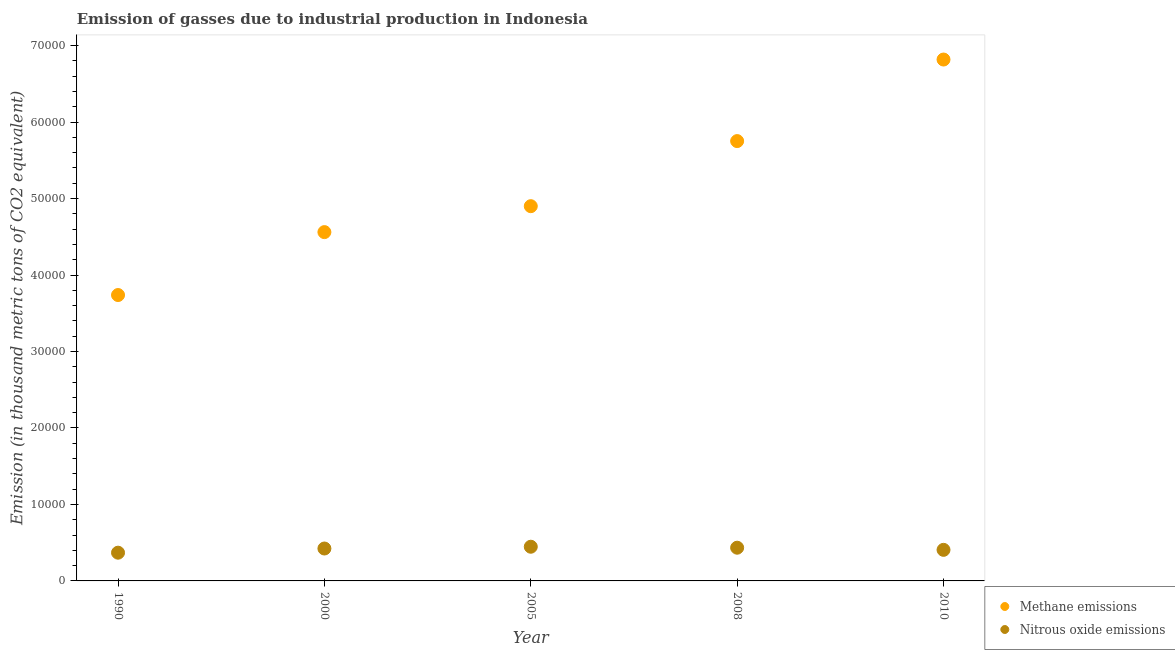What is the amount of methane emissions in 1990?
Provide a short and direct response. 3.74e+04. Across all years, what is the maximum amount of nitrous oxide emissions?
Keep it short and to the point. 4470.7. Across all years, what is the minimum amount of methane emissions?
Ensure brevity in your answer.  3.74e+04. In which year was the amount of nitrous oxide emissions minimum?
Your response must be concise. 1990. What is the total amount of methane emissions in the graph?
Your answer should be compact. 2.58e+05. What is the difference between the amount of nitrous oxide emissions in 2000 and that in 2010?
Make the answer very short. 174.5. What is the difference between the amount of methane emissions in 2010 and the amount of nitrous oxide emissions in 2008?
Provide a succinct answer. 6.38e+04. What is the average amount of methane emissions per year?
Offer a very short reply. 5.15e+04. In the year 2008, what is the difference between the amount of methane emissions and amount of nitrous oxide emissions?
Your answer should be compact. 5.32e+04. In how many years, is the amount of nitrous oxide emissions greater than 58000 thousand metric tons?
Your answer should be very brief. 0. What is the ratio of the amount of nitrous oxide emissions in 1990 to that in 2010?
Provide a succinct answer. 0.91. What is the difference between the highest and the second highest amount of methane emissions?
Make the answer very short. 1.07e+04. What is the difference between the highest and the lowest amount of nitrous oxide emissions?
Your response must be concise. 778.3. In how many years, is the amount of nitrous oxide emissions greater than the average amount of nitrous oxide emissions taken over all years?
Provide a succinct answer. 3. Does the amount of methane emissions monotonically increase over the years?
Provide a succinct answer. Yes. Is the amount of nitrous oxide emissions strictly greater than the amount of methane emissions over the years?
Your answer should be very brief. No. Is the amount of nitrous oxide emissions strictly less than the amount of methane emissions over the years?
Keep it short and to the point. Yes. How many dotlines are there?
Make the answer very short. 2. How many years are there in the graph?
Make the answer very short. 5. Are the values on the major ticks of Y-axis written in scientific E-notation?
Offer a terse response. No. Does the graph contain any zero values?
Keep it short and to the point. No. What is the title of the graph?
Your answer should be very brief. Emission of gasses due to industrial production in Indonesia. Does "Formally registered" appear as one of the legend labels in the graph?
Offer a terse response. No. What is the label or title of the X-axis?
Make the answer very short. Year. What is the label or title of the Y-axis?
Offer a very short reply. Emission (in thousand metric tons of CO2 equivalent). What is the Emission (in thousand metric tons of CO2 equivalent) in Methane emissions in 1990?
Offer a very short reply. 3.74e+04. What is the Emission (in thousand metric tons of CO2 equivalent) of Nitrous oxide emissions in 1990?
Provide a succinct answer. 3692.4. What is the Emission (in thousand metric tons of CO2 equivalent) of Methane emissions in 2000?
Give a very brief answer. 4.56e+04. What is the Emission (in thousand metric tons of CO2 equivalent) of Nitrous oxide emissions in 2000?
Your answer should be very brief. 4237.9. What is the Emission (in thousand metric tons of CO2 equivalent) of Methane emissions in 2005?
Your response must be concise. 4.90e+04. What is the Emission (in thousand metric tons of CO2 equivalent) in Nitrous oxide emissions in 2005?
Give a very brief answer. 4470.7. What is the Emission (in thousand metric tons of CO2 equivalent) of Methane emissions in 2008?
Ensure brevity in your answer.  5.75e+04. What is the Emission (in thousand metric tons of CO2 equivalent) of Nitrous oxide emissions in 2008?
Make the answer very short. 4343.7. What is the Emission (in thousand metric tons of CO2 equivalent) of Methane emissions in 2010?
Provide a short and direct response. 6.82e+04. What is the Emission (in thousand metric tons of CO2 equivalent) of Nitrous oxide emissions in 2010?
Offer a terse response. 4063.4. Across all years, what is the maximum Emission (in thousand metric tons of CO2 equivalent) of Methane emissions?
Make the answer very short. 6.82e+04. Across all years, what is the maximum Emission (in thousand metric tons of CO2 equivalent) of Nitrous oxide emissions?
Ensure brevity in your answer.  4470.7. Across all years, what is the minimum Emission (in thousand metric tons of CO2 equivalent) in Methane emissions?
Provide a short and direct response. 3.74e+04. Across all years, what is the minimum Emission (in thousand metric tons of CO2 equivalent) in Nitrous oxide emissions?
Provide a succinct answer. 3692.4. What is the total Emission (in thousand metric tons of CO2 equivalent) in Methane emissions in the graph?
Your response must be concise. 2.58e+05. What is the total Emission (in thousand metric tons of CO2 equivalent) in Nitrous oxide emissions in the graph?
Make the answer very short. 2.08e+04. What is the difference between the Emission (in thousand metric tons of CO2 equivalent) in Methane emissions in 1990 and that in 2000?
Your answer should be very brief. -8228.1. What is the difference between the Emission (in thousand metric tons of CO2 equivalent) in Nitrous oxide emissions in 1990 and that in 2000?
Offer a terse response. -545.5. What is the difference between the Emission (in thousand metric tons of CO2 equivalent) of Methane emissions in 1990 and that in 2005?
Provide a succinct answer. -1.16e+04. What is the difference between the Emission (in thousand metric tons of CO2 equivalent) in Nitrous oxide emissions in 1990 and that in 2005?
Make the answer very short. -778.3. What is the difference between the Emission (in thousand metric tons of CO2 equivalent) of Methane emissions in 1990 and that in 2008?
Your response must be concise. -2.01e+04. What is the difference between the Emission (in thousand metric tons of CO2 equivalent) in Nitrous oxide emissions in 1990 and that in 2008?
Offer a terse response. -651.3. What is the difference between the Emission (in thousand metric tons of CO2 equivalent) of Methane emissions in 1990 and that in 2010?
Your answer should be very brief. -3.08e+04. What is the difference between the Emission (in thousand metric tons of CO2 equivalent) in Nitrous oxide emissions in 1990 and that in 2010?
Offer a very short reply. -371. What is the difference between the Emission (in thousand metric tons of CO2 equivalent) of Methane emissions in 2000 and that in 2005?
Your answer should be very brief. -3391.6. What is the difference between the Emission (in thousand metric tons of CO2 equivalent) of Nitrous oxide emissions in 2000 and that in 2005?
Give a very brief answer. -232.8. What is the difference between the Emission (in thousand metric tons of CO2 equivalent) in Methane emissions in 2000 and that in 2008?
Your answer should be compact. -1.19e+04. What is the difference between the Emission (in thousand metric tons of CO2 equivalent) of Nitrous oxide emissions in 2000 and that in 2008?
Offer a terse response. -105.8. What is the difference between the Emission (in thousand metric tons of CO2 equivalent) of Methane emissions in 2000 and that in 2010?
Provide a succinct answer. -2.26e+04. What is the difference between the Emission (in thousand metric tons of CO2 equivalent) in Nitrous oxide emissions in 2000 and that in 2010?
Offer a terse response. 174.5. What is the difference between the Emission (in thousand metric tons of CO2 equivalent) of Methane emissions in 2005 and that in 2008?
Keep it short and to the point. -8512.6. What is the difference between the Emission (in thousand metric tons of CO2 equivalent) of Nitrous oxide emissions in 2005 and that in 2008?
Your answer should be compact. 127. What is the difference between the Emission (in thousand metric tons of CO2 equivalent) in Methane emissions in 2005 and that in 2010?
Provide a succinct answer. -1.92e+04. What is the difference between the Emission (in thousand metric tons of CO2 equivalent) of Nitrous oxide emissions in 2005 and that in 2010?
Offer a terse response. 407.3. What is the difference between the Emission (in thousand metric tons of CO2 equivalent) of Methane emissions in 2008 and that in 2010?
Offer a terse response. -1.07e+04. What is the difference between the Emission (in thousand metric tons of CO2 equivalent) of Nitrous oxide emissions in 2008 and that in 2010?
Your answer should be very brief. 280.3. What is the difference between the Emission (in thousand metric tons of CO2 equivalent) in Methane emissions in 1990 and the Emission (in thousand metric tons of CO2 equivalent) in Nitrous oxide emissions in 2000?
Provide a short and direct response. 3.31e+04. What is the difference between the Emission (in thousand metric tons of CO2 equivalent) in Methane emissions in 1990 and the Emission (in thousand metric tons of CO2 equivalent) in Nitrous oxide emissions in 2005?
Your response must be concise. 3.29e+04. What is the difference between the Emission (in thousand metric tons of CO2 equivalent) of Methane emissions in 1990 and the Emission (in thousand metric tons of CO2 equivalent) of Nitrous oxide emissions in 2008?
Provide a succinct answer. 3.30e+04. What is the difference between the Emission (in thousand metric tons of CO2 equivalent) of Methane emissions in 1990 and the Emission (in thousand metric tons of CO2 equivalent) of Nitrous oxide emissions in 2010?
Ensure brevity in your answer.  3.33e+04. What is the difference between the Emission (in thousand metric tons of CO2 equivalent) in Methane emissions in 2000 and the Emission (in thousand metric tons of CO2 equivalent) in Nitrous oxide emissions in 2005?
Keep it short and to the point. 4.11e+04. What is the difference between the Emission (in thousand metric tons of CO2 equivalent) in Methane emissions in 2000 and the Emission (in thousand metric tons of CO2 equivalent) in Nitrous oxide emissions in 2008?
Provide a succinct answer. 4.13e+04. What is the difference between the Emission (in thousand metric tons of CO2 equivalent) of Methane emissions in 2000 and the Emission (in thousand metric tons of CO2 equivalent) of Nitrous oxide emissions in 2010?
Offer a very short reply. 4.16e+04. What is the difference between the Emission (in thousand metric tons of CO2 equivalent) in Methane emissions in 2005 and the Emission (in thousand metric tons of CO2 equivalent) in Nitrous oxide emissions in 2008?
Your answer should be very brief. 4.47e+04. What is the difference between the Emission (in thousand metric tons of CO2 equivalent) in Methane emissions in 2005 and the Emission (in thousand metric tons of CO2 equivalent) in Nitrous oxide emissions in 2010?
Ensure brevity in your answer.  4.49e+04. What is the difference between the Emission (in thousand metric tons of CO2 equivalent) in Methane emissions in 2008 and the Emission (in thousand metric tons of CO2 equivalent) in Nitrous oxide emissions in 2010?
Ensure brevity in your answer.  5.35e+04. What is the average Emission (in thousand metric tons of CO2 equivalent) in Methane emissions per year?
Give a very brief answer. 5.15e+04. What is the average Emission (in thousand metric tons of CO2 equivalent) of Nitrous oxide emissions per year?
Provide a short and direct response. 4161.62. In the year 1990, what is the difference between the Emission (in thousand metric tons of CO2 equivalent) of Methane emissions and Emission (in thousand metric tons of CO2 equivalent) of Nitrous oxide emissions?
Make the answer very short. 3.37e+04. In the year 2000, what is the difference between the Emission (in thousand metric tons of CO2 equivalent) in Methane emissions and Emission (in thousand metric tons of CO2 equivalent) in Nitrous oxide emissions?
Provide a succinct answer. 4.14e+04. In the year 2005, what is the difference between the Emission (in thousand metric tons of CO2 equivalent) in Methane emissions and Emission (in thousand metric tons of CO2 equivalent) in Nitrous oxide emissions?
Ensure brevity in your answer.  4.45e+04. In the year 2008, what is the difference between the Emission (in thousand metric tons of CO2 equivalent) of Methane emissions and Emission (in thousand metric tons of CO2 equivalent) of Nitrous oxide emissions?
Provide a succinct answer. 5.32e+04. In the year 2010, what is the difference between the Emission (in thousand metric tons of CO2 equivalent) of Methane emissions and Emission (in thousand metric tons of CO2 equivalent) of Nitrous oxide emissions?
Make the answer very short. 6.41e+04. What is the ratio of the Emission (in thousand metric tons of CO2 equivalent) in Methane emissions in 1990 to that in 2000?
Your answer should be compact. 0.82. What is the ratio of the Emission (in thousand metric tons of CO2 equivalent) of Nitrous oxide emissions in 1990 to that in 2000?
Give a very brief answer. 0.87. What is the ratio of the Emission (in thousand metric tons of CO2 equivalent) in Methane emissions in 1990 to that in 2005?
Offer a very short reply. 0.76. What is the ratio of the Emission (in thousand metric tons of CO2 equivalent) in Nitrous oxide emissions in 1990 to that in 2005?
Ensure brevity in your answer.  0.83. What is the ratio of the Emission (in thousand metric tons of CO2 equivalent) of Methane emissions in 1990 to that in 2008?
Offer a very short reply. 0.65. What is the ratio of the Emission (in thousand metric tons of CO2 equivalent) of Nitrous oxide emissions in 1990 to that in 2008?
Provide a short and direct response. 0.85. What is the ratio of the Emission (in thousand metric tons of CO2 equivalent) in Methane emissions in 1990 to that in 2010?
Your response must be concise. 0.55. What is the ratio of the Emission (in thousand metric tons of CO2 equivalent) of Nitrous oxide emissions in 1990 to that in 2010?
Your answer should be compact. 0.91. What is the ratio of the Emission (in thousand metric tons of CO2 equivalent) in Methane emissions in 2000 to that in 2005?
Provide a short and direct response. 0.93. What is the ratio of the Emission (in thousand metric tons of CO2 equivalent) of Nitrous oxide emissions in 2000 to that in 2005?
Give a very brief answer. 0.95. What is the ratio of the Emission (in thousand metric tons of CO2 equivalent) in Methane emissions in 2000 to that in 2008?
Offer a very short reply. 0.79. What is the ratio of the Emission (in thousand metric tons of CO2 equivalent) of Nitrous oxide emissions in 2000 to that in 2008?
Ensure brevity in your answer.  0.98. What is the ratio of the Emission (in thousand metric tons of CO2 equivalent) in Methane emissions in 2000 to that in 2010?
Keep it short and to the point. 0.67. What is the ratio of the Emission (in thousand metric tons of CO2 equivalent) of Nitrous oxide emissions in 2000 to that in 2010?
Offer a very short reply. 1.04. What is the ratio of the Emission (in thousand metric tons of CO2 equivalent) of Methane emissions in 2005 to that in 2008?
Your answer should be very brief. 0.85. What is the ratio of the Emission (in thousand metric tons of CO2 equivalent) in Nitrous oxide emissions in 2005 to that in 2008?
Your answer should be very brief. 1.03. What is the ratio of the Emission (in thousand metric tons of CO2 equivalent) of Methane emissions in 2005 to that in 2010?
Provide a short and direct response. 0.72. What is the ratio of the Emission (in thousand metric tons of CO2 equivalent) in Nitrous oxide emissions in 2005 to that in 2010?
Ensure brevity in your answer.  1.1. What is the ratio of the Emission (in thousand metric tons of CO2 equivalent) in Methane emissions in 2008 to that in 2010?
Offer a terse response. 0.84. What is the ratio of the Emission (in thousand metric tons of CO2 equivalent) of Nitrous oxide emissions in 2008 to that in 2010?
Keep it short and to the point. 1.07. What is the difference between the highest and the second highest Emission (in thousand metric tons of CO2 equivalent) of Methane emissions?
Offer a very short reply. 1.07e+04. What is the difference between the highest and the second highest Emission (in thousand metric tons of CO2 equivalent) in Nitrous oxide emissions?
Provide a short and direct response. 127. What is the difference between the highest and the lowest Emission (in thousand metric tons of CO2 equivalent) in Methane emissions?
Offer a very short reply. 3.08e+04. What is the difference between the highest and the lowest Emission (in thousand metric tons of CO2 equivalent) in Nitrous oxide emissions?
Your response must be concise. 778.3. 